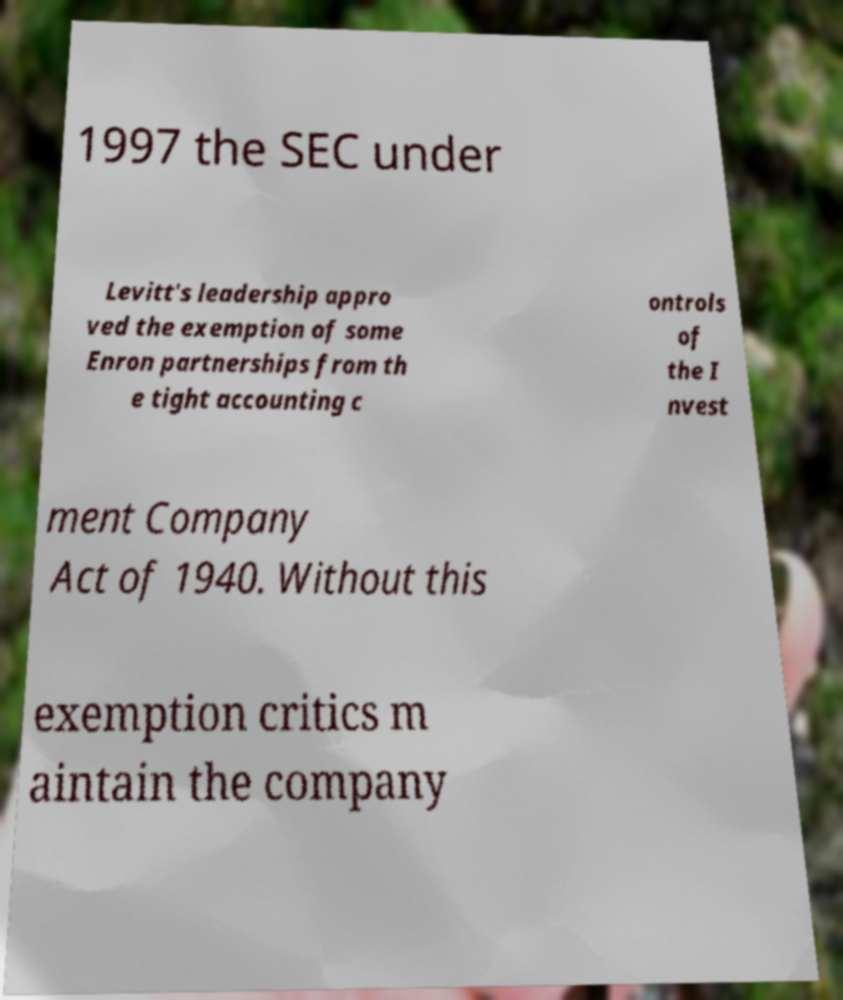Can you accurately transcribe the text from the provided image for me? 1997 the SEC under Levitt's leadership appro ved the exemption of some Enron partnerships from th e tight accounting c ontrols of the I nvest ment Company Act of 1940. Without this exemption critics m aintain the company 